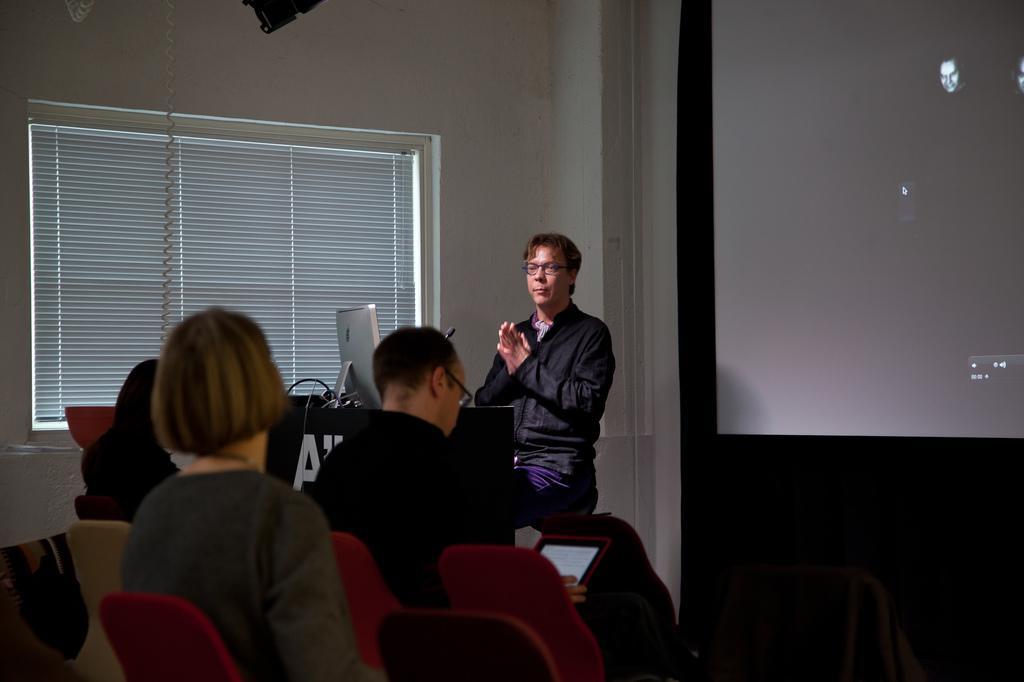In one or two sentences, can you explain what this image depicts? In the center of the image we ca see a man sitting, before him there is a podium and we can see a computer placed on the podium. there are people sitting on the chairs. on the right there is a screen. On the left we can see a window and blinds. In the background there is a wall. 